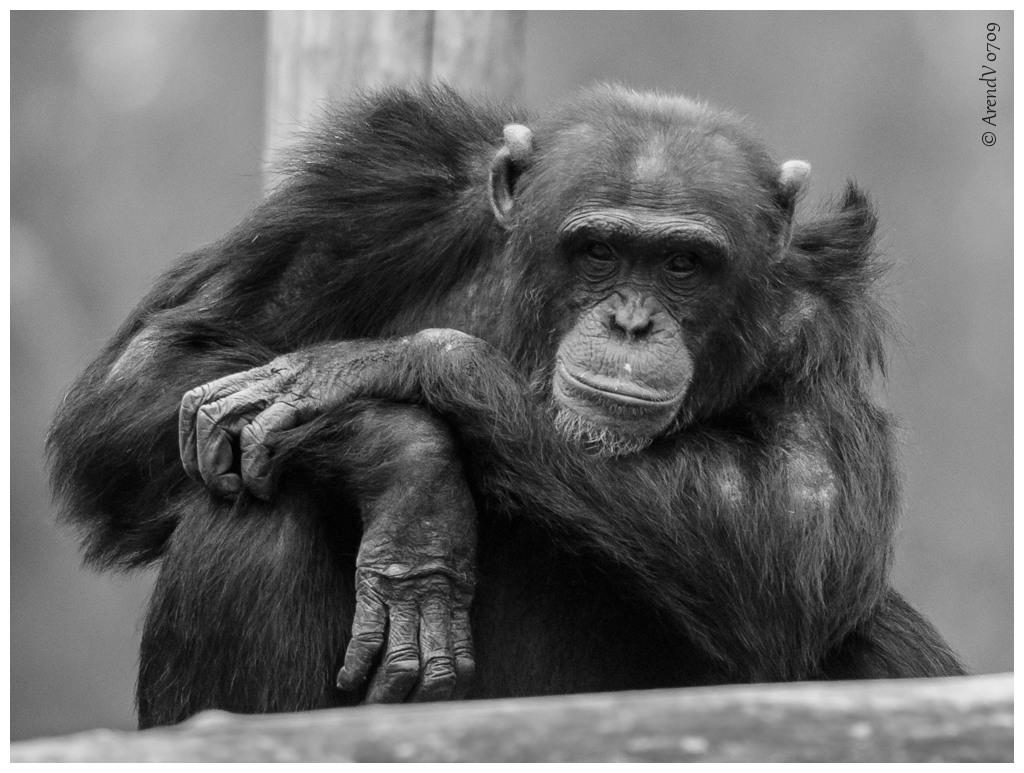What animal is the main subject of the picture? There is a chimpanzee in the picture. Can you describe the background of the image? The background of the picture is blurry. Is there any text present in the image? Yes, there is text visible at the right top of the image. How many bears can be seen playing in the rainstorm in the image? There are no bears or rainstorm present in the image; it features a chimpanzee with a blurry background and text at the top right. What type of vase is visible in the image? There is no vase present in the image. 